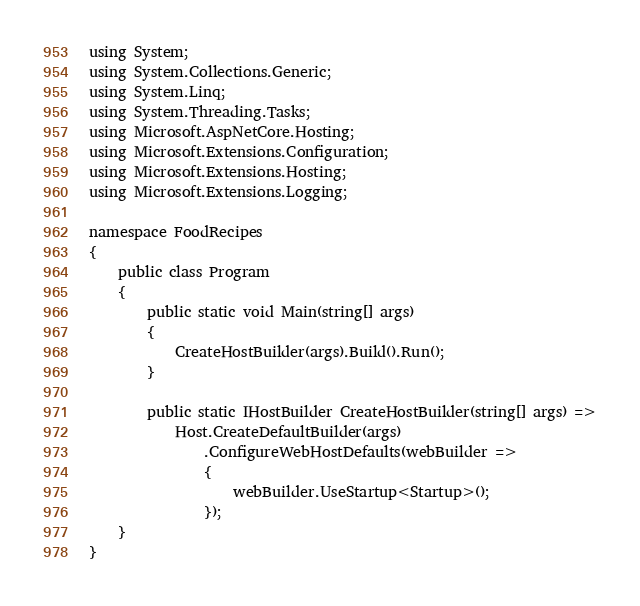Convert code to text. <code><loc_0><loc_0><loc_500><loc_500><_C#_>using System;
using System.Collections.Generic;
using System.Linq;
using System.Threading.Tasks;
using Microsoft.AspNetCore.Hosting;
using Microsoft.Extensions.Configuration;
using Microsoft.Extensions.Hosting;
using Microsoft.Extensions.Logging;

namespace FoodRecipes
{
    public class Program
    {
        public static void Main(string[] args)
        {
            CreateHostBuilder(args).Build().Run();
        }

        public static IHostBuilder CreateHostBuilder(string[] args) =>
            Host.CreateDefaultBuilder(args)
                .ConfigureWebHostDefaults(webBuilder =>
                {
                    webBuilder.UseStartup<Startup>();
                });
    }
}
</code> 